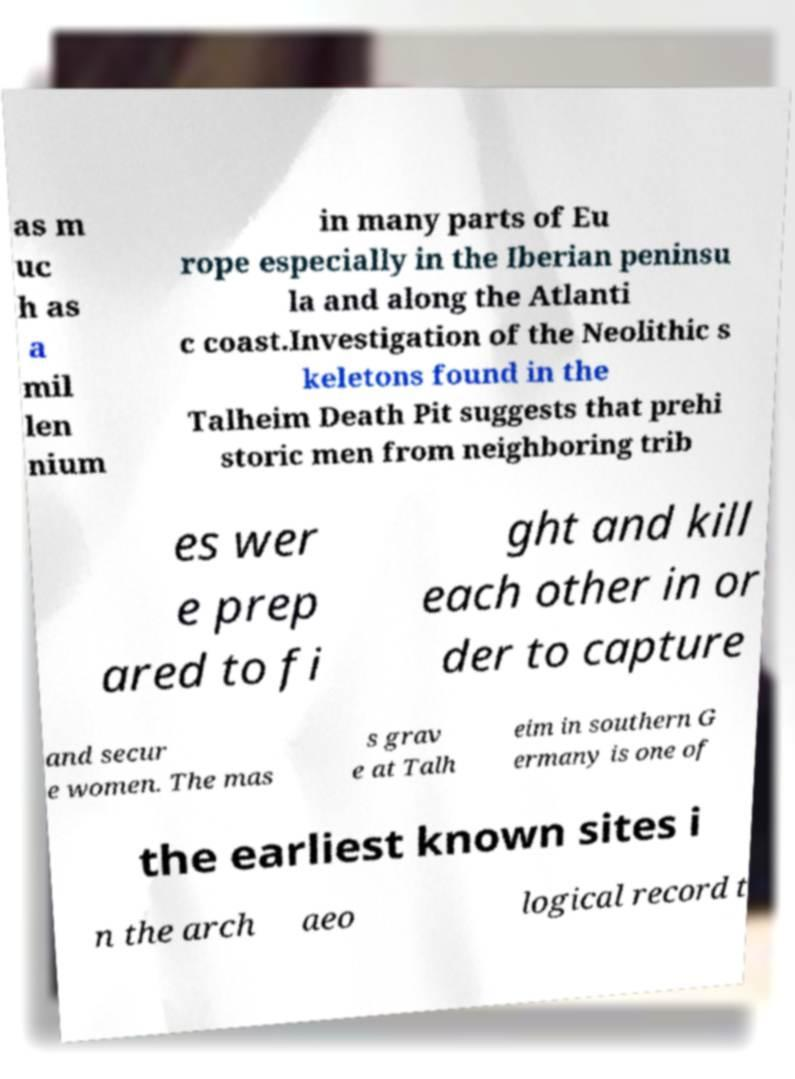Can you read and provide the text displayed in the image?This photo seems to have some interesting text. Can you extract and type it out for me? as m uc h as a mil len nium in many parts of Eu rope especially in the Iberian peninsu la and along the Atlanti c coast.Investigation of the Neolithic s keletons found in the Talheim Death Pit suggests that prehi storic men from neighboring trib es wer e prep ared to fi ght and kill each other in or der to capture and secur e women. The mas s grav e at Talh eim in southern G ermany is one of the earliest known sites i n the arch aeo logical record t 